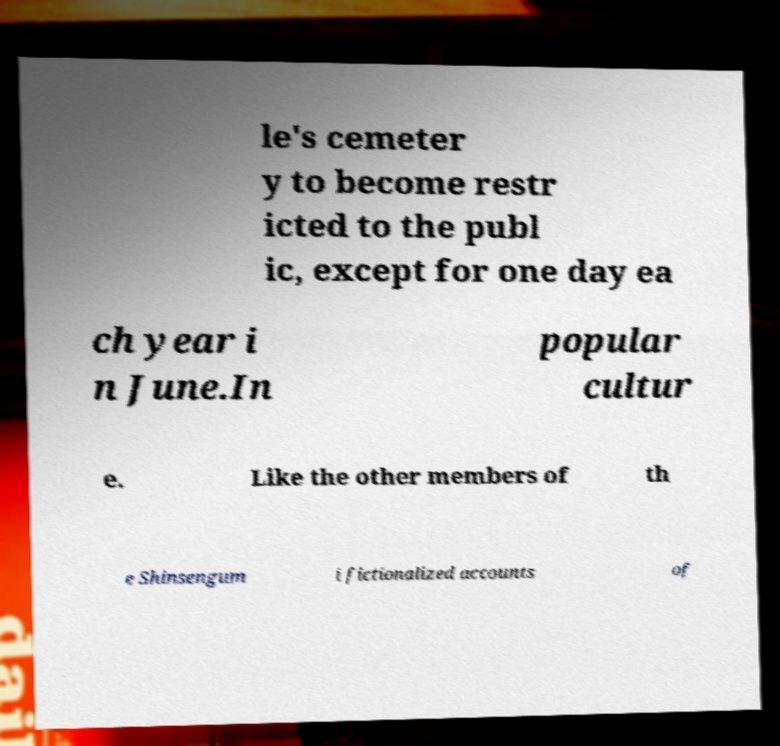Please read and relay the text visible in this image. What does it say? le's cemeter y to become restr icted to the publ ic, except for one day ea ch year i n June.In popular cultur e. Like the other members of th e Shinsengum i fictionalized accounts of 